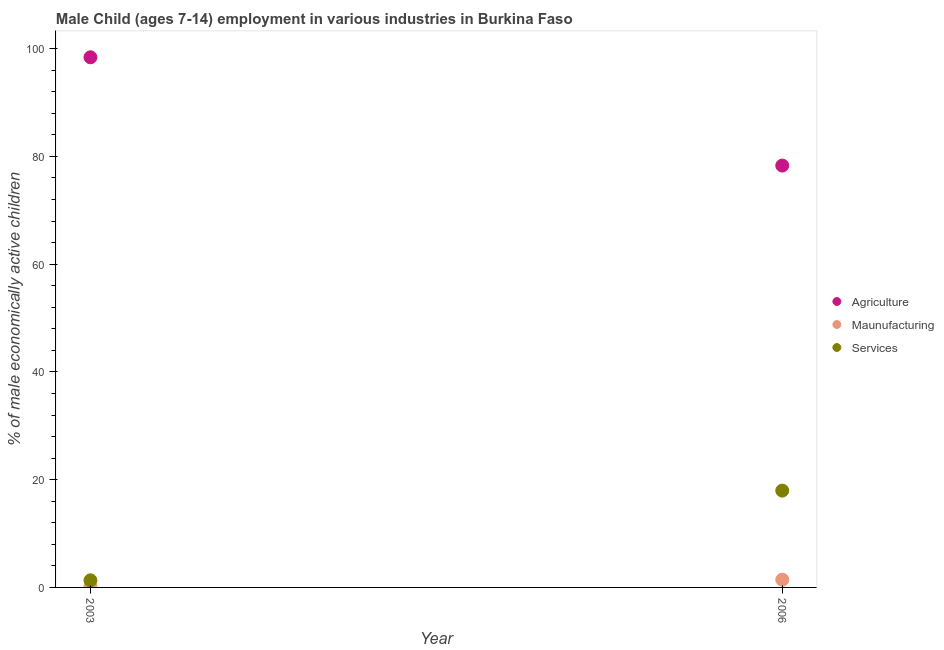Is the number of dotlines equal to the number of legend labels?
Your answer should be very brief. Yes. What is the percentage of economically active children in agriculture in 2003?
Offer a terse response. 98.4. Across all years, what is the maximum percentage of economically active children in manufacturing?
Ensure brevity in your answer.  1.44. In which year was the percentage of economically active children in services maximum?
Your answer should be compact. 2006. What is the total percentage of economically active children in manufacturing in the graph?
Your answer should be compact. 1.64. What is the difference between the percentage of economically active children in services in 2003 and that in 2006?
Offer a terse response. -16.65. What is the difference between the percentage of economically active children in services in 2003 and the percentage of economically active children in agriculture in 2006?
Keep it short and to the point. -76.98. What is the average percentage of economically active children in manufacturing per year?
Provide a short and direct response. 0.82. In the year 2003, what is the difference between the percentage of economically active children in agriculture and percentage of economically active children in manufacturing?
Keep it short and to the point. 98.2. In how many years, is the percentage of economically active children in agriculture greater than 76 %?
Your answer should be compact. 2. What is the ratio of the percentage of economically active children in services in 2003 to that in 2006?
Your answer should be compact. 0.07. In how many years, is the percentage of economically active children in services greater than the average percentage of economically active children in services taken over all years?
Your answer should be compact. 1. Is it the case that in every year, the sum of the percentage of economically active children in agriculture and percentage of economically active children in manufacturing is greater than the percentage of economically active children in services?
Your answer should be very brief. Yes. Is the percentage of economically active children in services strictly greater than the percentage of economically active children in manufacturing over the years?
Provide a short and direct response. Yes. How many dotlines are there?
Keep it short and to the point. 3. How many years are there in the graph?
Offer a terse response. 2. Are the values on the major ticks of Y-axis written in scientific E-notation?
Provide a short and direct response. No. Does the graph contain any zero values?
Your answer should be very brief. No. Where does the legend appear in the graph?
Ensure brevity in your answer.  Center right. What is the title of the graph?
Provide a succinct answer. Male Child (ages 7-14) employment in various industries in Burkina Faso. What is the label or title of the Y-axis?
Your response must be concise. % of male economically active children. What is the % of male economically active children in Agriculture in 2003?
Your response must be concise. 98.4. What is the % of male economically active children in Maunufacturing in 2003?
Your answer should be compact. 0.2. What is the % of male economically active children in Services in 2003?
Provide a succinct answer. 1.32. What is the % of male economically active children of Agriculture in 2006?
Your answer should be very brief. 78.3. What is the % of male economically active children in Maunufacturing in 2006?
Your answer should be very brief. 1.44. What is the % of male economically active children of Services in 2006?
Ensure brevity in your answer.  17.97. Across all years, what is the maximum % of male economically active children of Agriculture?
Offer a terse response. 98.4. Across all years, what is the maximum % of male economically active children of Maunufacturing?
Make the answer very short. 1.44. Across all years, what is the maximum % of male economically active children in Services?
Provide a short and direct response. 17.97. Across all years, what is the minimum % of male economically active children of Agriculture?
Make the answer very short. 78.3. Across all years, what is the minimum % of male economically active children in Maunufacturing?
Your answer should be compact. 0.2. Across all years, what is the minimum % of male economically active children of Services?
Offer a terse response. 1.32. What is the total % of male economically active children of Agriculture in the graph?
Your answer should be compact. 176.7. What is the total % of male economically active children of Maunufacturing in the graph?
Keep it short and to the point. 1.64. What is the total % of male economically active children of Services in the graph?
Your answer should be compact. 19.29. What is the difference between the % of male economically active children in Agriculture in 2003 and that in 2006?
Offer a very short reply. 20.1. What is the difference between the % of male economically active children in Maunufacturing in 2003 and that in 2006?
Your response must be concise. -1.24. What is the difference between the % of male economically active children in Services in 2003 and that in 2006?
Your answer should be compact. -16.65. What is the difference between the % of male economically active children in Agriculture in 2003 and the % of male economically active children in Maunufacturing in 2006?
Your answer should be very brief. 96.96. What is the difference between the % of male economically active children of Agriculture in 2003 and the % of male economically active children of Services in 2006?
Offer a very short reply. 80.43. What is the difference between the % of male economically active children of Maunufacturing in 2003 and the % of male economically active children of Services in 2006?
Ensure brevity in your answer.  -17.77. What is the average % of male economically active children in Agriculture per year?
Offer a terse response. 88.35. What is the average % of male economically active children in Maunufacturing per year?
Keep it short and to the point. 0.82. What is the average % of male economically active children of Services per year?
Provide a succinct answer. 9.65. In the year 2003, what is the difference between the % of male economically active children in Agriculture and % of male economically active children in Maunufacturing?
Offer a terse response. 98.2. In the year 2003, what is the difference between the % of male economically active children of Agriculture and % of male economically active children of Services?
Give a very brief answer. 97.08. In the year 2003, what is the difference between the % of male economically active children in Maunufacturing and % of male economically active children in Services?
Make the answer very short. -1.12. In the year 2006, what is the difference between the % of male economically active children of Agriculture and % of male economically active children of Maunufacturing?
Your answer should be very brief. 76.86. In the year 2006, what is the difference between the % of male economically active children of Agriculture and % of male economically active children of Services?
Make the answer very short. 60.33. In the year 2006, what is the difference between the % of male economically active children in Maunufacturing and % of male economically active children in Services?
Make the answer very short. -16.53. What is the ratio of the % of male economically active children of Agriculture in 2003 to that in 2006?
Your answer should be compact. 1.26. What is the ratio of the % of male economically active children of Maunufacturing in 2003 to that in 2006?
Make the answer very short. 0.14. What is the ratio of the % of male economically active children in Services in 2003 to that in 2006?
Keep it short and to the point. 0.07. What is the difference between the highest and the second highest % of male economically active children in Agriculture?
Provide a short and direct response. 20.1. What is the difference between the highest and the second highest % of male economically active children in Maunufacturing?
Provide a succinct answer. 1.24. What is the difference between the highest and the second highest % of male economically active children of Services?
Offer a very short reply. 16.65. What is the difference between the highest and the lowest % of male economically active children of Agriculture?
Keep it short and to the point. 20.1. What is the difference between the highest and the lowest % of male economically active children of Maunufacturing?
Keep it short and to the point. 1.24. What is the difference between the highest and the lowest % of male economically active children in Services?
Give a very brief answer. 16.65. 